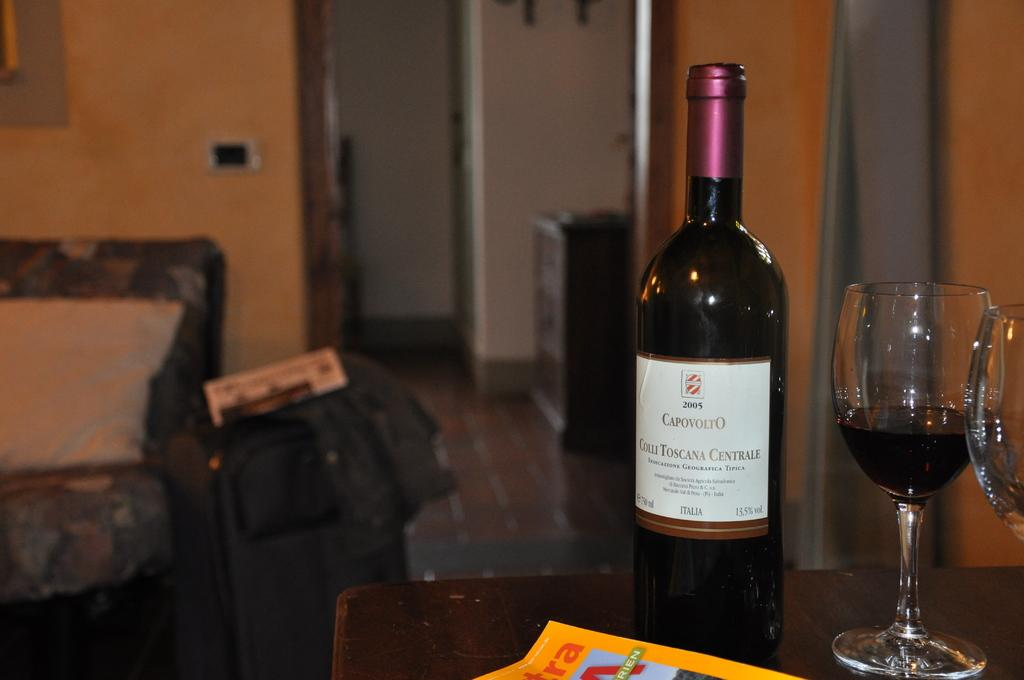<image>
Share a concise interpretation of the image provided. A glass of Capovolto wine sits next to the bottle. 